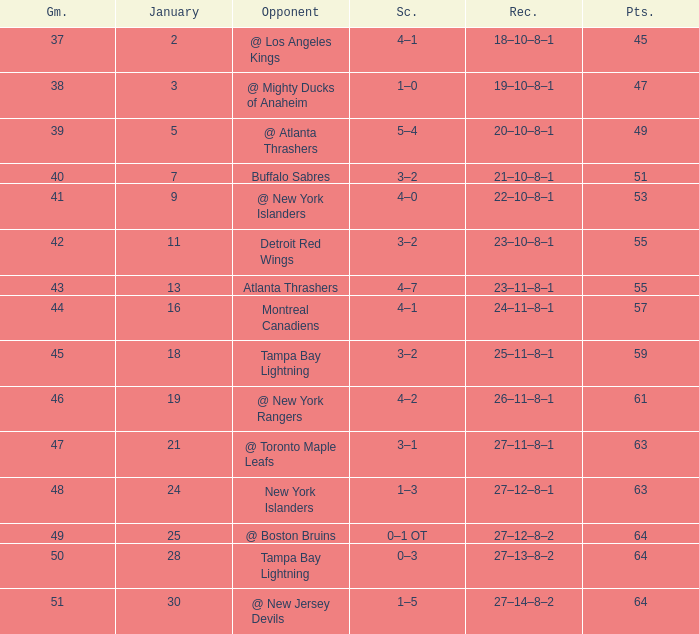How many Games have a Score of 5–4, and Points smaller than 49? 0.0. 